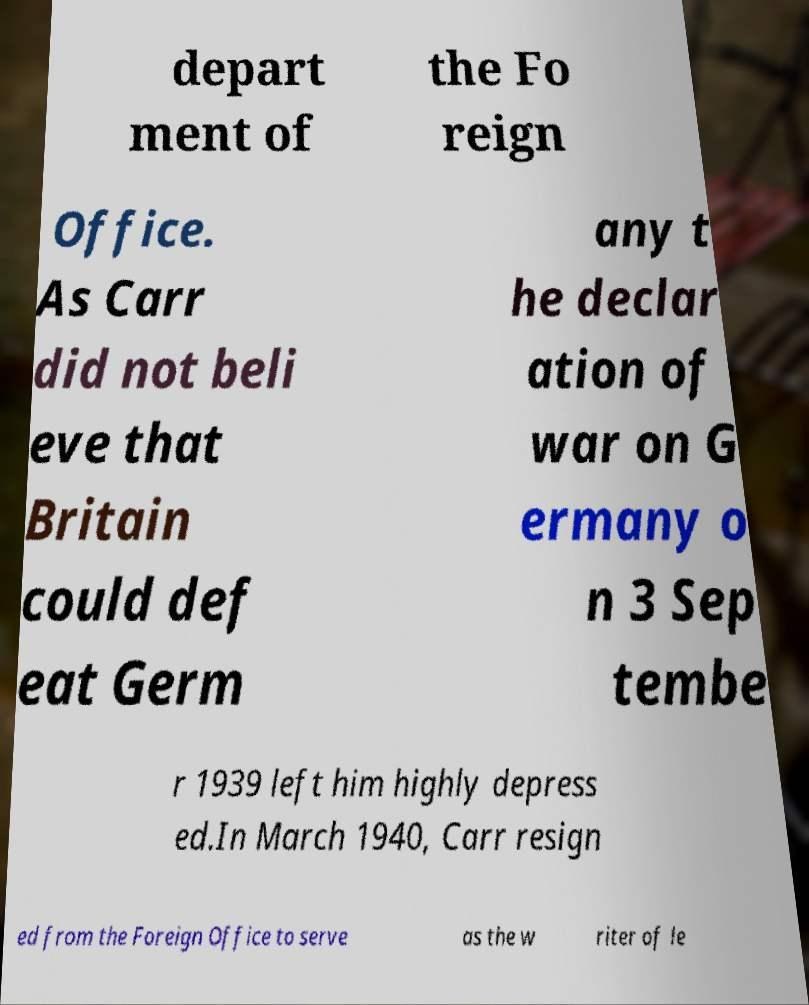Can you read and provide the text displayed in the image?This photo seems to have some interesting text. Can you extract and type it out for me? depart ment of the Fo reign Office. As Carr did not beli eve that Britain could def eat Germ any t he declar ation of war on G ermany o n 3 Sep tembe r 1939 left him highly depress ed.In March 1940, Carr resign ed from the Foreign Office to serve as the w riter of le 